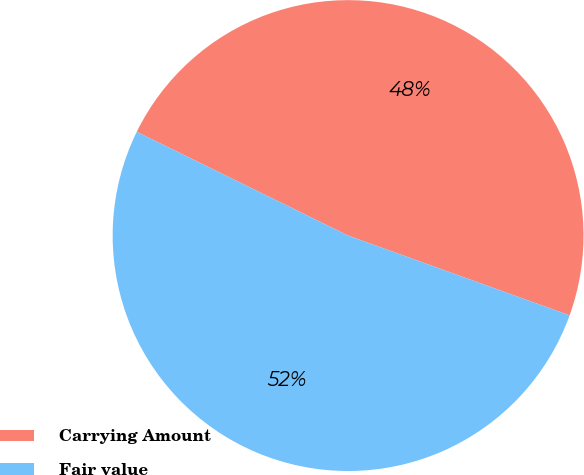Convert chart to OTSL. <chart><loc_0><loc_0><loc_500><loc_500><pie_chart><fcel>Carrying Amount<fcel>Fair value<nl><fcel>48.24%<fcel>51.76%<nl></chart> 